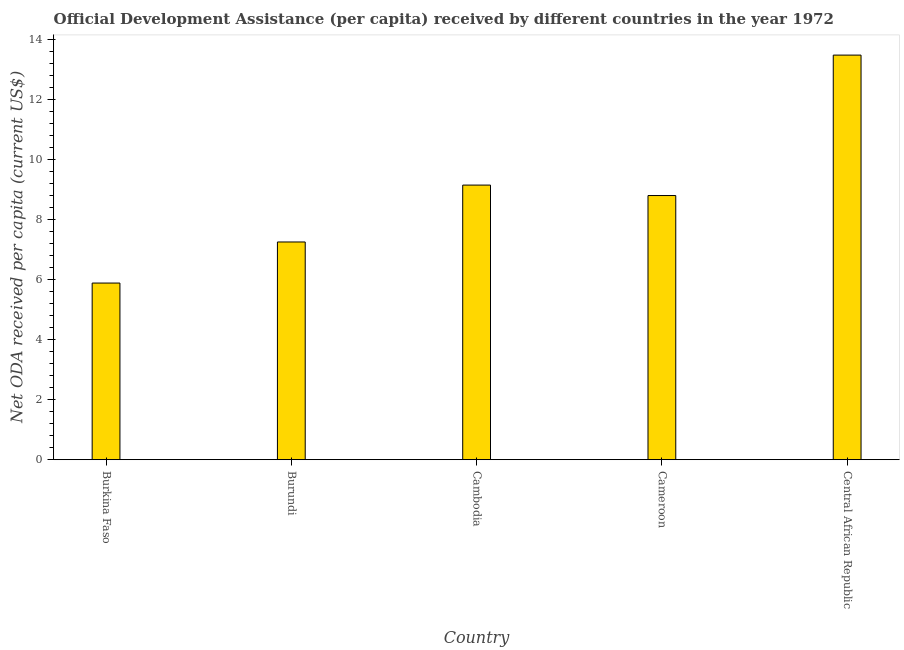Does the graph contain any zero values?
Your answer should be compact. No. What is the title of the graph?
Ensure brevity in your answer.  Official Development Assistance (per capita) received by different countries in the year 1972. What is the label or title of the X-axis?
Keep it short and to the point. Country. What is the label or title of the Y-axis?
Give a very brief answer. Net ODA received per capita (current US$). What is the net oda received per capita in Burundi?
Your answer should be very brief. 7.26. Across all countries, what is the maximum net oda received per capita?
Your answer should be very brief. 13.5. Across all countries, what is the minimum net oda received per capita?
Your response must be concise. 5.89. In which country was the net oda received per capita maximum?
Give a very brief answer. Central African Republic. In which country was the net oda received per capita minimum?
Your response must be concise. Burkina Faso. What is the sum of the net oda received per capita?
Ensure brevity in your answer.  44.62. What is the difference between the net oda received per capita in Burundi and Cameroon?
Give a very brief answer. -1.55. What is the average net oda received per capita per country?
Offer a very short reply. 8.92. What is the median net oda received per capita?
Provide a short and direct response. 8.81. What is the ratio of the net oda received per capita in Burundi to that in Cameroon?
Your response must be concise. 0.82. Is the net oda received per capita in Burundi less than that in Central African Republic?
Give a very brief answer. Yes. Is the difference between the net oda received per capita in Burkina Faso and Cameroon greater than the difference between any two countries?
Make the answer very short. No. What is the difference between the highest and the second highest net oda received per capita?
Your answer should be compact. 4.33. Is the sum of the net oda received per capita in Burkina Faso and Cameroon greater than the maximum net oda received per capita across all countries?
Your response must be concise. Yes. What is the difference between the highest and the lowest net oda received per capita?
Your answer should be compact. 7.6. How many bars are there?
Offer a very short reply. 5. Are all the bars in the graph horizontal?
Your response must be concise. No. Are the values on the major ticks of Y-axis written in scientific E-notation?
Ensure brevity in your answer.  No. What is the Net ODA received per capita (current US$) in Burkina Faso?
Ensure brevity in your answer.  5.89. What is the Net ODA received per capita (current US$) of Burundi?
Provide a succinct answer. 7.26. What is the Net ODA received per capita (current US$) in Cambodia?
Keep it short and to the point. 9.16. What is the Net ODA received per capita (current US$) in Cameroon?
Your answer should be very brief. 8.81. What is the Net ODA received per capita (current US$) of Central African Republic?
Your response must be concise. 13.5. What is the difference between the Net ODA received per capita (current US$) in Burkina Faso and Burundi?
Your response must be concise. -1.37. What is the difference between the Net ODA received per capita (current US$) in Burkina Faso and Cambodia?
Offer a terse response. -3.27. What is the difference between the Net ODA received per capita (current US$) in Burkina Faso and Cameroon?
Give a very brief answer. -2.92. What is the difference between the Net ODA received per capita (current US$) in Burkina Faso and Central African Republic?
Offer a terse response. -7.6. What is the difference between the Net ODA received per capita (current US$) in Burundi and Cambodia?
Your answer should be compact. -1.9. What is the difference between the Net ODA received per capita (current US$) in Burundi and Cameroon?
Give a very brief answer. -1.55. What is the difference between the Net ODA received per capita (current US$) in Burundi and Central African Republic?
Make the answer very short. -6.23. What is the difference between the Net ODA received per capita (current US$) in Cambodia and Cameroon?
Keep it short and to the point. 0.35. What is the difference between the Net ODA received per capita (current US$) in Cambodia and Central African Republic?
Your response must be concise. -4.34. What is the difference between the Net ODA received per capita (current US$) in Cameroon and Central African Republic?
Ensure brevity in your answer.  -4.68. What is the ratio of the Net ODA received per capita (current US$) in Burkina Faso to that in Burundi?
Provide a short and direct response. 0.81. What is the ratio of the Net ODA received per capita (current US$) in Burkina Faso to that in Cambodia?
Offer a very short reply. 0.64. What is the ratio of the Net ODA received per capita (current US$) in Burkina Faso to that in Cameroon?
Your response must be concise. 0.67. What is the ratio of the Net ODA received per capita (current US$) in Burkina Faso to that in Central African Republic?
Give a very brief answer. 0.44. What is the ratio of the Net ODA received per capita (current US$) in Burundi to that in Cambodia?
Your answer should be compact. 0.79. What is the ratio of the Net ODA received per capita (current US$) in Burundi to that in Cameroon?
Ensure brevity in your answer.  0.82. What is the ratio of the Net ODA received per capita (current US$) in Burundi to that in Central African Republic?
Provide a short and direct response. 0.54. What is the ratio of the Net ODA received per capita (current US$) in Cambodia to that in Central African Republic?
Your answer should be compact. 0.68. What is the ratio of the Net ODA received per capita (current US$) in Cameroon to that in Central African Republic?
Offer a terse response. 0.65. 